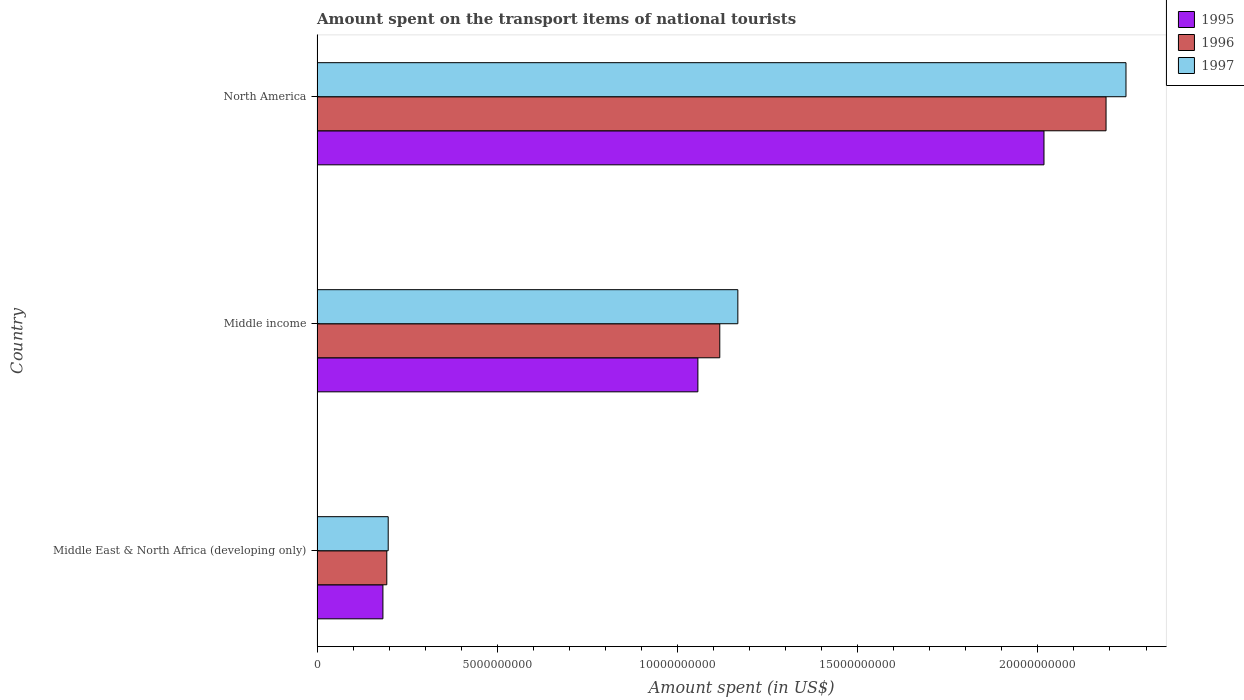How many different coloured bars are there?
Your answer should be compact. 3. Are the number of bars per tick equal to the number of legend labels?
Offer a terse response. Yes. In how many cases, is the number of bars for a given country not equal to the number of legend labels?
Your response must be concise. 0. What is the amount spent on the transport items of national tourists in 1995 in North America?
Provide a succinct answer. 2.02e+1. Across all countries, what is the maximum amount spent on the transport items of national tourists in 1996?
Offer a very short reply. 2.19e+1. Across all countries, what is the minimum amount spent on the transport items of national tourists in 1997?
Your answer should be compact. 1.97e+09. In which country was the amount spent on the transport items of national tourists in 1996 minimum?
Keep it short and to the point. Middle East & North Africa (developing only). What is the total amount spent on the transport items of national tourists in 1995 in the graph?
Your answer should be very brief. 3.26e+1. What is the difference between the amount spent on the transport items of national tourists in 1995 in Middle East & North Africa (developing only) and that in North America?
Keep it short and to the point. -1.83e+1. What is the difference between the amount spent on the transport items of national tourists in 1996 in Middle income and the amount spent on the transport items of national tourists in 1997 in Middle East & North Africa (developing only)?
Keep it short and to the point. 9.20e+09. What is the average amount spent on the transport items of national tourists in 1997 per country?
Your answer should be compact. 1.20e+1. What is the difference between the amount spent on the transport items of national tourists in 1997 and amount spent on the transport items of national tourists in 1995 in North America?
Your response must be concise. 2.28e+09. What is the ratio of the amount spent on the transport items of national tourists in 1995 in Middle income to that in North America?
Your response must be concise. 0.52. Is the amount spent on the transport items of national tourists in 1997 in Middle income less than that in North America?
Give a very brief answer. Yes. What is the difference between the highest and the second highest amount spent on the transport items of national tourists in 1996?
Your answer should be compact. 1.07e+1. What is the difference between the highest and the lowest amount spent on the transport items of national tourists in 1996?
Provide a succinct answer. 2.00e+1. In how many countries, is the amount spent on the transport items of national tourists in 1996 greater than the average amount spent on the transport items of national tourists in 1996 taken over all countries?
Offer a very short reply. 1. Is the sum of the amount spent on the transport items of national tourists in 1996 in Middle East & North Africa (developing only) and Middle income greater than the maximum amount spent on the transport items of national tourists in 1997 across all countries?
Provide a short and direct response. No. What does the 3rd bar from the top in Middle income represents?
Ensure brevity in your answer.  1995. Are all the bars in the graph horizontal?
Make the answer very short. Yes. How many countries are there in the graph?
Make the answer very short. 3. What is the difference between two consecutive major ticks on the X-axis?
Keep it short and to the point. 5.00e+09. Does the graph contain any zero values?
Make the answer very short. No. How many legend labels are there?
Your answer should be very brief. 3. How are the legend labels stacked?
Offer a very short reply. Vertical. What is the title of the graph?
Offer a very short reply. Amount spent on the transport items of national tourists. Does "1970" appear as one of the legend labels in the graph?
Keep it short and to the point. No. What is the label or title of the X-axis?
Give a very brief answer. Amount spent (in US$). What is the label or title of the Y-axis?
Your response must be concise. Country. What is the Amount spent (in US$) of 1995 in Middle East & North Africa (developing only)?
Your answer should be very brief. 1.83e+09. What is the Amount spent (in US$) in 1996 in Middle East & North Africa (developing only)?
Provide a succinct answer. 1.94e+09. What is the Amount spent (in US$) in 1997 in Middle East & North Africa (developing only)?
Provide a short and direct response. 1.97e+09. What is the Amount spent (in US$) in 1995 in Middle income?
Your answer should be very brief. 1.06e+1. What is the Amount spent (in US$) in 1996 in Middle income?
Your answer should be compact. 1.12e+1. What is the Amount spent (in US$) of 1997 in Middle income?
Keep it short and to the point. 1.17e+1. What is the Amount spent (in US$) of 1995 in North America?
Keep it short and to the point. 2.02e+1. What is the Amount spent (in US$) of 1996 in North America?
Ensure brevity in your answer.  2.19e+1. What is the Amount spent (in US$) in 1997 in North America?
Your answer should be very brief. 2.24e+1. Across all countries, what is the maximum Amount spent (in US$) in 1995?
Your answer should be very brief. 2.02e+1. Across all countries, what is the maximum Amount spent (in US$) of 1996?
Give a very brief answer. 2.19e+1. Across all countries, what is the maximum Amount spent (in US$) of 1997?
Offer a terse response. 2.24e+1. Across all countries, what is the minimum Amount spent (in US$) in 1995?
Ensure brevity in your answer.  1.83e+09. Across all countries, what is the minimum Amount spent (in US$) in 1996?
Offer a very short reply. 1.94e+09. Across all countries, what is the minimum Amount spent (in US$) of 1997?
Your answer should be compact. 1.97e+09. What is the total Amount spent (in US$) in 1995 in the graph?
Ensure brevity in your answer.  3.26e+1. What is the total Amount spent (in US$) in 1996 in the graph?
Your answer should be very brief. 3.50e+1. What is the total Amount spent (in US$) in 1997 in the graph?
Provide a short and direct response. 3.61e+1. What is the difference between the Amount spent (in US$) in 1995 in Middle East & North Africa (developing only) and that in Middle income?
Offer a terse response. -8.74e+09. What is the difference between the Amount spent (in US$) in 1996 in Middle East & North Africa (developing only) and that in Middle income?
Give a very brief answer. -9.24e+09. What is the difference between the Amount spent (in US$) in 1997 in Middle East & North Africa (developing only) and that in Middle income?
Your answer should be compact. -9.70e+09. What is the difference between the Amount spent (in US$) in 1995 in Middle East & North Africa (developing only) and that in North America?
Provide a short and direct response. -1.83e+1. What is the difference between the Amount spent (in US$) in 1996 in Middle East & North Africa (developing only) and that in North America?
Offer a terse response. -2.00e+1. What is the difference between the Amount spent (in US$) in 1997 in Middle East & North Africa (developing only) and that in North America?
Give a very brief answer. -2.05e+1. What is the difference between the Amount spent (in US$) in 1995 in Middle income and that in North America?
Your answer should be compact. -9.60e+09. What is the difference between the Amount spent (in US$) of 1996 in Middle income and that in North America?
Your answer should be very brief. -1.07e+1. What is the difference between the Amount spent (in US$) of 1997 in Middle income and that in North America?
Make the answer very short. -1.08e+1. What is the difference between the Amount spent (in US$) in 1995 in Middle East & North Africa (developing only) and the Amount spent (in US$) in 1996 in Middle income?
Ensure brevity in your answer.  -9.35e+09. What is the difference between the Amount spent (in US$) of 1995 in Middle East & North Africa (developing only) and the Amount spent (in US$) of 1997 in Middle income?
Your response must be concise. -9.85e+09. What is the difference between the Amount spent (in US$) in 1996 in Middle East & North Africa (developing only) and the Amount spent (in US$) in 1997 in Middle income?
Provide a succinct answer. -9.74e+09. What is the difference between the Amount spent (in US$) in 1995 in Middle East & North Africa (developing only) and the Amount spent (in US$) in 1996 in North America?
Provide a short and direct response. -2.01e+1. What is the difference between the Amount spent (in US$) of 1995 in Middle East & North Africa (developing only) and the Amount spent (in US$) of 1997 in North America?
Offer a very short reply. -2.06e+1. What is the difference between the Amount spent (in US$) in 1996 in Middle East & North Africa (developing only) and the Amount spent (in US$) in 1997 in North America?
Keep it short and to the point. -2.05e+1. What is the difference between the Amount spent (in US$) of 1995 in Middle income and the Amount spent (in US$) of 1996 in North America?
Your response must be concise. -1.13e+1. What is the difference between the Amount spent (in US$) of 1995 in Middle income and the Amount spent (in US$) of 1997 in North America?
Your response must be concise. -1.19e+1. What is the difference between the Amount spent (in US$) of 1996 in Middle income and the Amount spent (in US$) of 1997 in North America?
Provide a succinct answer. -1.13e+1. What is the average Amount spent (in US$) in 1995 per country?
Ensure brevity in your answer.  1.09e+1. What is the average Amount spent (in US$) of 1996 per country?
Your answer should be very brief. 1.17e+1. What is the average Amount spent (in US$) in 1997 per country?
Your answer should be compact. 1.20e+1. What is the difference between the Amount spent (in US$) of 1995 and Amount spent (in US$) of 1996 in Middle East & North Africa (developing only)?
Offer a very short reply. -1.08e+08. What is the difference between the Amount spent (in US$) in 1995 and Amount spent (in US$) in 1997 in Middle East & North Africa (developing only)?
Offer a terse response. -1.47e+08. What is the difference between the Amount spent (in US$) of 1996 and Amount spent (in US$) of 1997 in Middle East & North Africa (developing only)?
Keep it short and to the point. -3.92e+07. What is the difference between the Amount spent (in US$) in 1995 and Amount spent (in US$) in 1996 in Middle income?
Provide a succinct answer. -6.08e+08. What is the difference between the Amount spent (in US$) of 1995 and Amount spent (in US$) of 1997 in Middle income?
Provide a short and direct response. -1.11e+09. What is the difference between the Amount spent (in US$) in 1996 and Amount spent (in US$) in 1997 in Middle income?
Give a very brief answer. -5.01e+08. What is the difference between the Amount spent (in US$) in 1995 and Amount spent (in US$) in 1996 in North America?
Your response must be concise. -1.72e+09. What is the difference between the Amount spent (in US$) of 1995 and Amount spent (in US$) of 1997 in North America?
Your response must be concise. -2.28e+09. What is the difference between the Amount spent (in US$) of 1996 and Amount spent (in US$) of 1997 in North America?
Give a very brief answer. -5.53e+08. What is the ratio of the Amount spent (in US$) in 1995 in Middle East & North Africa (developing only) to that in Middle income?
Offer a terse response. 0.17. What is the ratio of the Amount spent (in US$) of 1996 in Middle East & North Africa (developing only) to that in Middle income?
Your answer should be compact. 0.17. What is the ratio of the Amount spent (in US$) in 1997 in Middle East & North Africa (developing only) to that in Middle income?
Your answer should be compact. 0.17. What is the ratio of the Amount spent (in US$) in 1995 in Middle East & North Africa (developing only) to that in North America?
Make the answer very short. 0.09. What is the ratio of the Amount spent (in US$) of 1996 in Middle East & North Africa (developing only) to that in North America?
Your answer should be compact. 0.09. What is the ratio of the Amount spent (in US$) in 1997 in Middle East & North Africa (developing only) to that in North America?
Your answer should be compact. 0.09. What is the ratio of the Amount spent (in US$) of 1995 in Middle income to that in North America?
Your answer should be compact. 0.52. What is the ratio of the Amount spent (in US$) of 1996 in Middle income to that in North America?
Ensure brevity in your answer.  0.51. What is the ratio of the Amount spent (in US$) of 1997 in Middle income to that in North America?
Make the answer very short. 0.52. What is the difference between the highest and the second highest Amount spent (in US$) of 1995?
Keep it short and to the point. 9.60e+09. What is the difference between the highest and the second highest Amount spent (in US$) in 1996?
Your answer should be compact. 1.07e+1. What is the difference between the highest and the second highest Amount spent (in US$) in 1997?
Your response must be concise. 1.08e+1. What is the difference between the highest and the lowest Amount spent (in US$) in 1995?
Provide a short and direct response. 1.83e+1. What is the difference between the highest and the lowest Amount spent (in US$) in 1996?
Your answer should be very brief. 2.00e+1. What is the difference between the highest and the lowest Amount spent (in US$) in 1997?
Your response must be concise. 2.05e+1. 